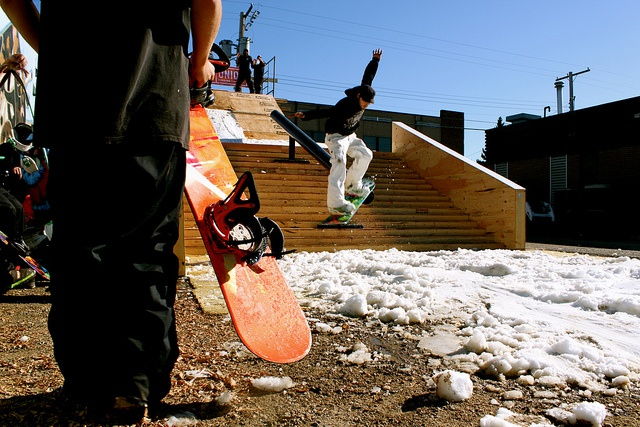Describe the objects in this image and their specific colors. I can see people in maroon, black, olive, and gray tones, skateboard in maroon, orange, black, and tan tones, snowboard in maroon, orange, tan, and black tones, people in maroon, black, darkgray, white, and gray tones, and people in maroon, black, olive, and gray tones in this image. 